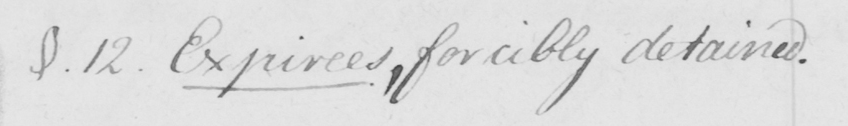Please transcribe the handwritten text in this image. §.12 . Expirees , forcibly detained . 